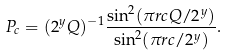<formula> <loc_0><loc_0><loc_500><loc_500>P _ { c } = ( 2 ^ { y } Q ) ^ { - 1 } \frac { \sin ^ { 2 } ( \pi r c Q / 2 ^ { y } ) } { \sin ^ { 2 } ( \pi r c / 2 ^ { y } ) } .</formula> 